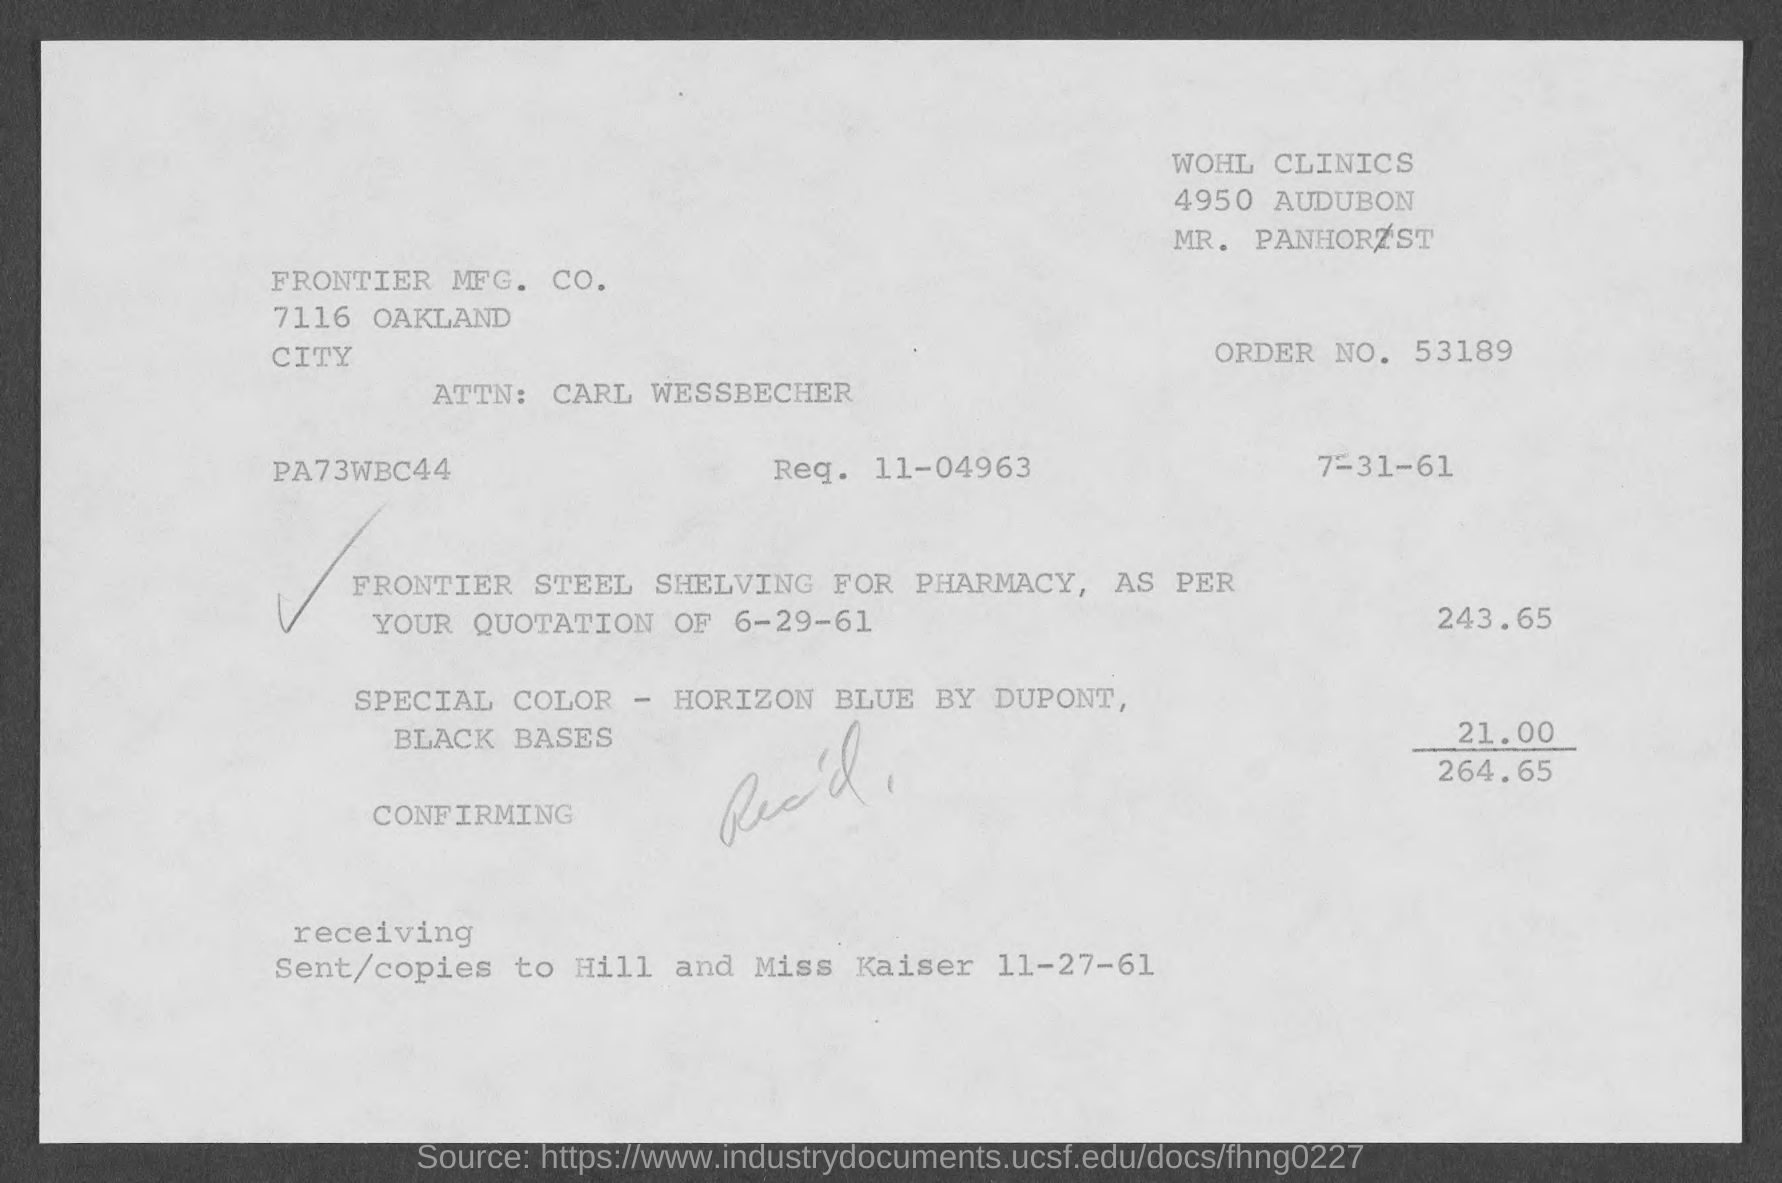Point out several critical features in this image. I have requested order number 53189 and am awaiting its delivery. 